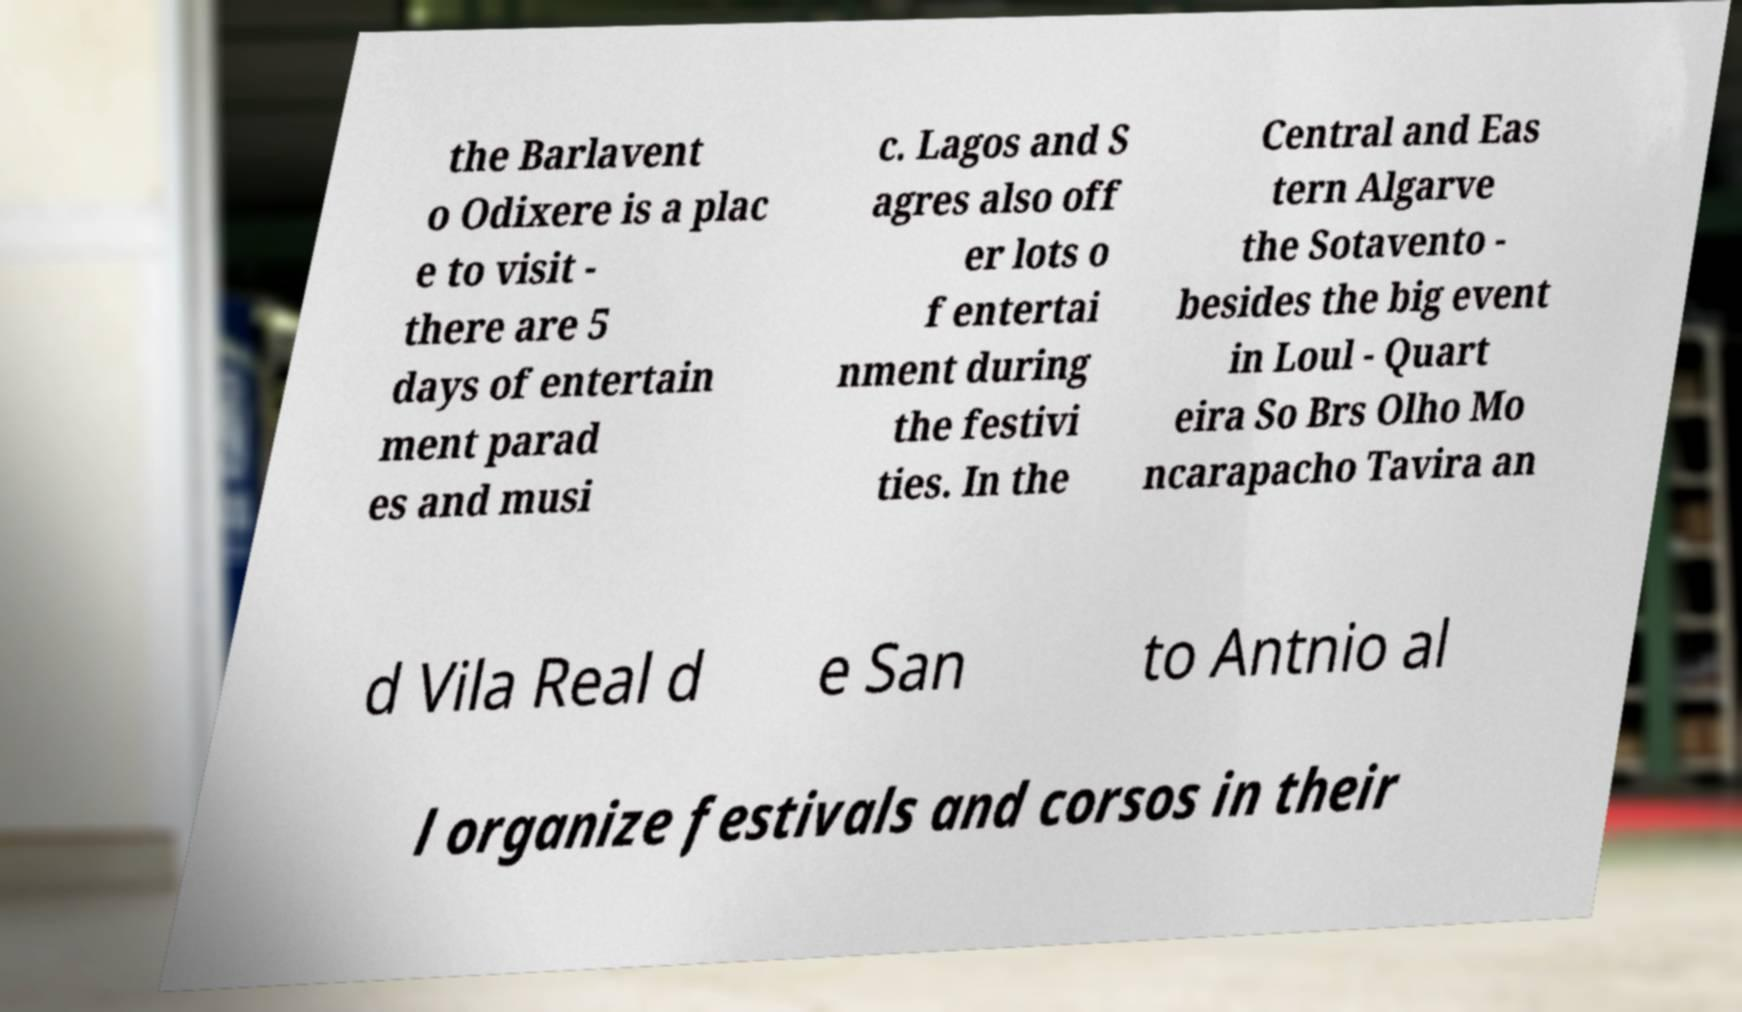Please read and relay the text visible in this image. What does it say? the Barlavent o Odixere is a plac e to visit - there are 5 days of entertain ment parad es and musi c. Lagos and S agres also off er lots o f entertai nment during the festivi ties. In the Central and Eas tern Algarve the Sotavento - besides the big event in Loul - Quart eira So Brs Olho Mo ncarapacho Tavira an d Vila Real d e San to Antnio al l organize festivals and corsos in their 